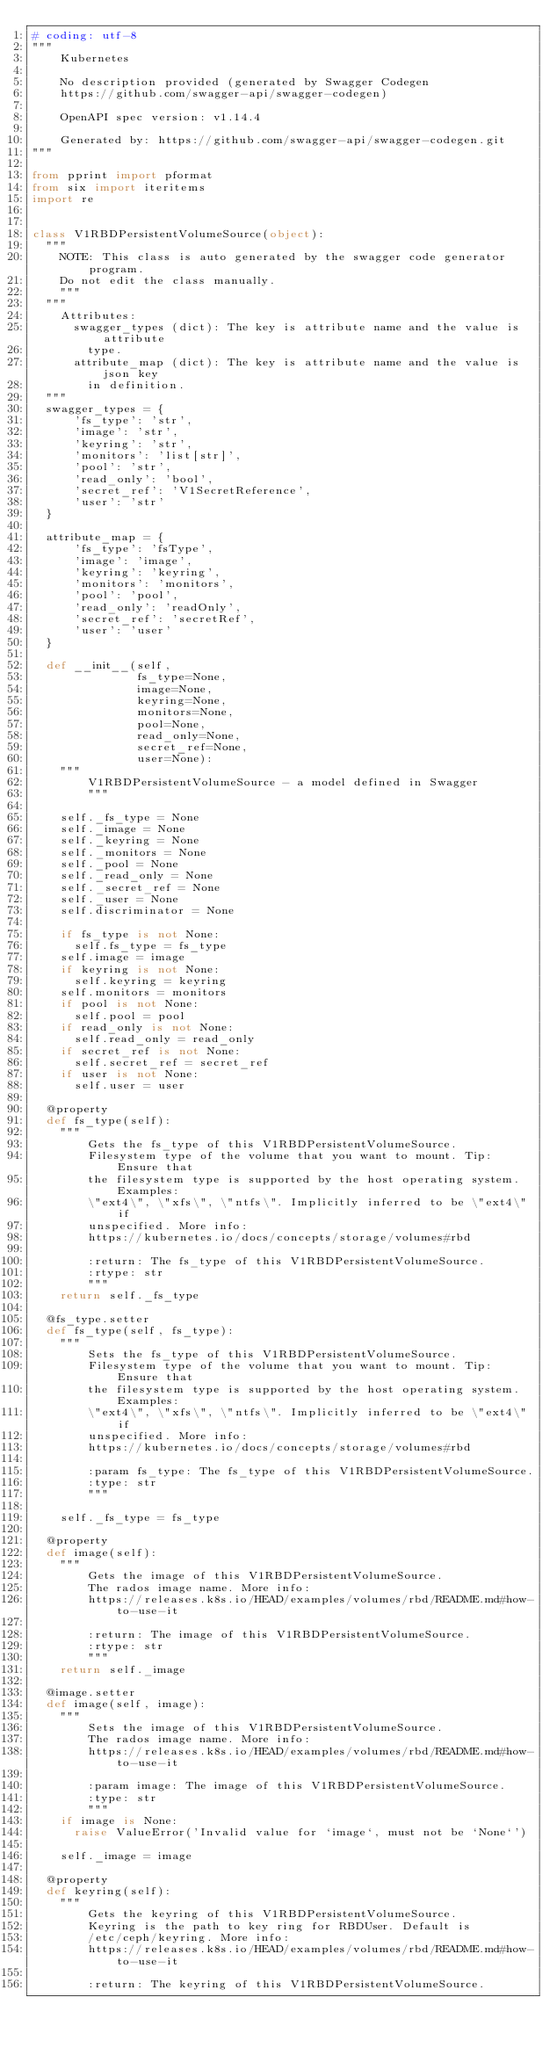Convert code to text. <code><loc_0><loc_0><loc_500><loc_500><_Python_># coding: utf-8
"""
    Kubernetes

    No description provided (generated by Swagger Codegen
    https://github.com/swagger-api/swagger-codegen)

    OpenAPI spec version: v1.14.4

    Generated by: https://github.com/swagger-api/swagger-codegen.git
"""

from pprint import pformat
from six import iteritems
import re


class V1RBDPersistentVolumeSource(object):
  """
    NOTE: This class is auto generated by the swagger code generator program.
    Do not edit the class manually.
    """
  """
    Attributes:
      swagger_types (dict): The key is attribute name and the value is attribute
        type.
      attribute_map (dict): The key is attribute name and the value is json key
        in definition.
  """
  swagger_types = {
      'fs_type': 'str',
      'image': 'str',
      'keyring': 'str',
      'monitors': 'list[str]',
      'pool': 'str',
      'read_only': 'bool',
      'secret_ref': 'V1SecretReference',
      'user': 'str'
  }

  attribute_map = {
      'fs_type': 'fsType',
      'image': 'image',
      'keyring': 'keyring',
      'monitors': 'monitors',
      'pool': 'pool',
      'read_only': 'readOnly',
      'secret_ref': 'secretRef',
      'user': 'user'
  }

  def __init__(self,
               fs_type=None,
               image=None,
               keyring=None,
               monitors=None,
               pool=None,
               read_only=None,
               secret_ref=None,
               user=None):
    """
        V1RBDPersistentVolumeSource - a model defined in Swagger
        """

    self._fs_type = None
    self._image = None
    self._keyring = None
    self._monitors = None
    self._pool = None
    self._read_only = None
    self._secret_ref = None
    self._user = None
    self.discriminator = None

    if fs_type is not None:
      self.fs_type = fs_type
    self.image = image
    if keyring is not None:
      self.keyring = keyring
    self.monitors = monitors
    if pool is not None:
      self.pool = pool
    if read_only is not None:
      self.read_only = read_only
    if secret_ref is not None:
      self.secret_ref = secret_ref
    if user is not None:
      self.user = user

  @property
  def fs_type(self):
    """
        Gets the fs_type of this V1RBDPersistentVolumeSource.
        Filesystem type of the volume that you want to mount. Tip: Ensure that
        the filesystem type is supported by the host operating system. Examples:
        \"ext4\", \"xfs\", \"ntfs\". Implicitly inferred to be \"ext4\" if
        unspecified. More info:
        https://kubernetes.io/docs/concepts/storage/volumes#rbd

        :return: The fs_type of this V1RBDPersistentVolumeSource.
        :rtype: str
        """
    return self._fs_type

  @fs_type.setter
  def fs_type(self, fs_type):
    """
        Sets the fs_type of this V1RBDPersistentVolumeSource.
        Filesystem type of the volume that you want to mount. Tip: Ensure that
        the filesystem type is supported by the host operating system. Examples:
        \"ext4\", \"xfs\", \"ntfs\". Implicitly inferred to be \"ext4\" if
        unspecified. More info:
        https://kubernetes.io/docs/concepts/storage/volumes#rbd

        :param fs_type: The fs_type of this V1RBDPersistentVolumeSource.
        :type: str
        """

    self._fs_type = fs_type

  @property
  def image(self):
    """
        Gets the image of this V1RBDPersistentVolumeSource.
        The rados image name. More info:
        https://releases.k8s.io/HEAD/examples/volumes/rbd/README.md#how-to-use-it

        :return: The image of this V1RBDPersistentVolumeSource.
        :rtype: str
        """
    return self._image

  @image.setter
  def image(self, image):
    """
        Sets the image of this V1RBDPersistentVolumeSource.
        The rados image name. More info:
        https://releases.k8s.io/HEAD/examples/volumes/rbd/README.md#how-to-use-it

        :param image: The image of this V1RBDPersistentVolumeSource.
        :type: str
        """
    if image is None:
      raise ValueError('Invalid value for `image`, must not be `None`')

    self._image = image

  @property
  def keyring(self):
    """
        Gets the keyring of this V1RBDPersistentVolumeSource.
        Keyring is the path to key ring for RBDUser. Default is
        /etc/ceph/keyring. More info:
        https://releases.k8s.io/HEAD/examples/volumes/rbd/README.md#how-to-use-it

        :return: The keyring of this V1RBDPersistentVolumeSource.</code> 